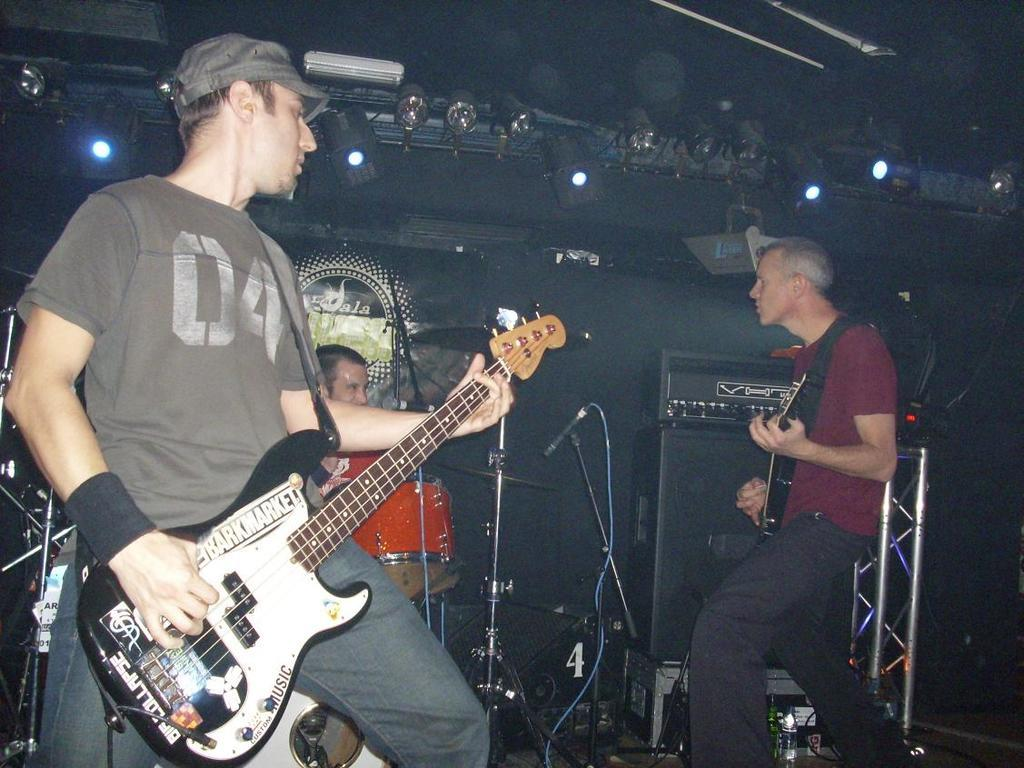How many people are in the image? There are three men in the image. What are two of the men doing? Two of the men are holding guitars. What is the third man doing? The third man is playing drums. What can be seen in the background of the image? There are lights and equipment visible in the background of the image. What type of quill is the man using to play the drums in the image? There is no quill present in the image, and the man playing drums is using drumsticks, not a quill. What time of day is it in the image, considering the presence of leaves? There is no mention of leaves in the image, and the time of day cannot be determined from the information provided. 